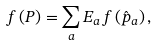Convert formula to latex. <formula><loc_0><loc_0><loc_500><loc_500>f \left ( P \right ) = \sum _ { a } E _ { a } f \left ( \hat { p } _ { a } \right ) ,</formula> 